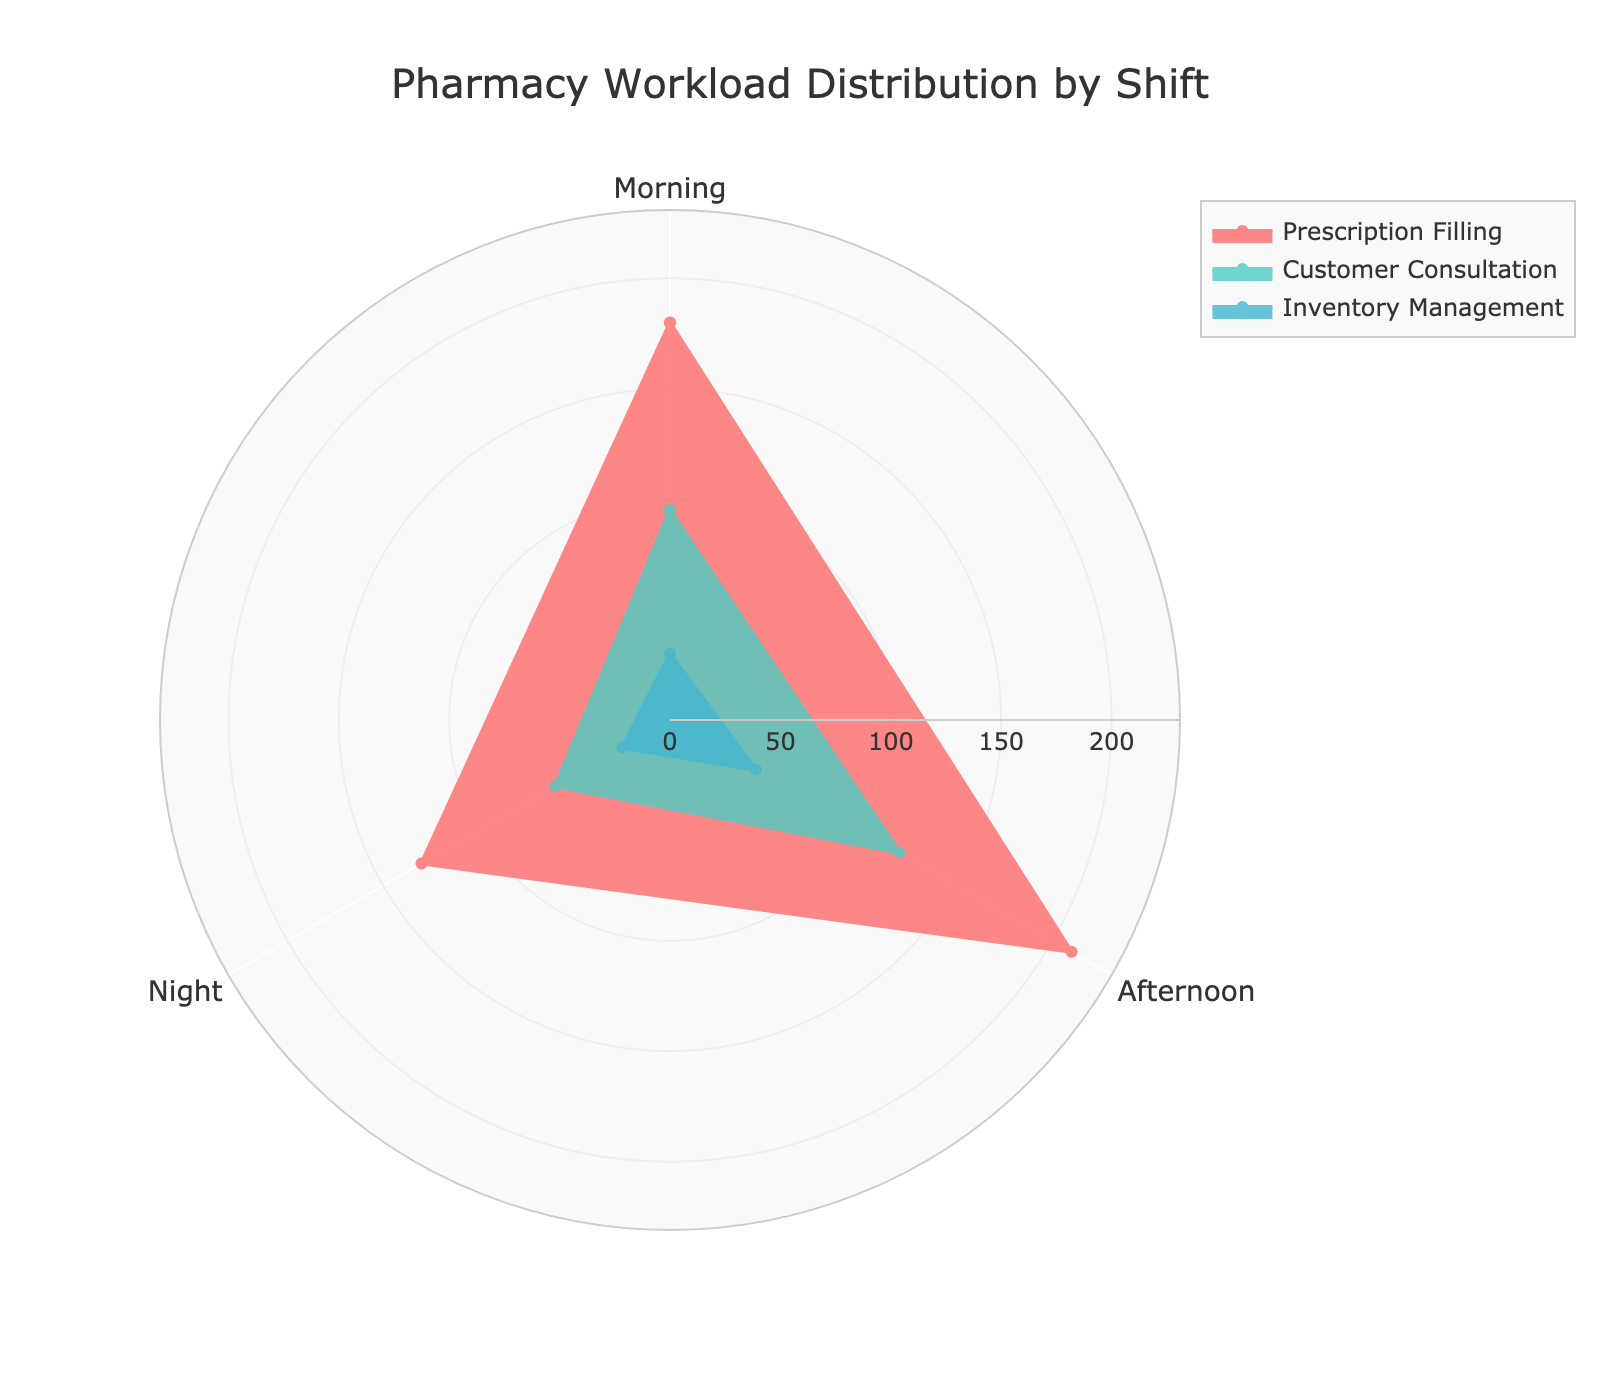What is the title of the chart? The title is usually at the top of the chart and serves as an immediate summary of what the chart represents.
Answer: Pharmacy Workload Distribution by Shift Which shift has the highest workload for prescription filling? Looking at the lengths of the sections associated with 'Prescription Filling' in each shift, the Afternoon segment appears to have the greatest length.
Answer: Afternoon How many shifts are represented in the chart? Count the unique radial segments representing different shifts in the chart.
Answer: 3 What is the least common task in the Night shift? By comparing the lengths of the three tasks within the Night shift segment, 'Inventory Management' has the lowest value.
Answer: Inventory Management What is the total workload for Customer Consultation across all shifts? Sum the values for 'Customer Consultation' across all shifts: 95 (Morning) + 120 (Afternoon) + 60 (Night).
Answer: 275 Which shift has the lowest workload for Inventory Management? Compare the lengths of the 'Inventory Management' segments across all shifts and identify the shortest one, which is the Night shift.
Answer: Night What is the difference in the prescription filling workload between the Morning and the Afternoon shifts? Subtract the value for Morning (180) from that of Afternoon (210).
Answer: 30 How does the Morning shift's Prescription Filling workload compare to the Night shift's Prescription Filling workload? Compare the lengths of the 'Prescription Filling' segments for Morning and Night shifts with Morning being larger at 180 and Night at 130.
Answer: Morning is greater What is the common feature shared by all shifts for each task? Each shift has segments of equal color-coded tasks (Prescription Filling, Customer Consultation, Inventory Management).
Answer: They have all three tasks What is the average workload for Inventory Management across all shifts? Sum the values for 'Inventory Management' across all shifts: 30 (Morning) + 45 (Afternoon) + 25 (Night), and divide by the number of shifts which is 3.
Answer: 33 